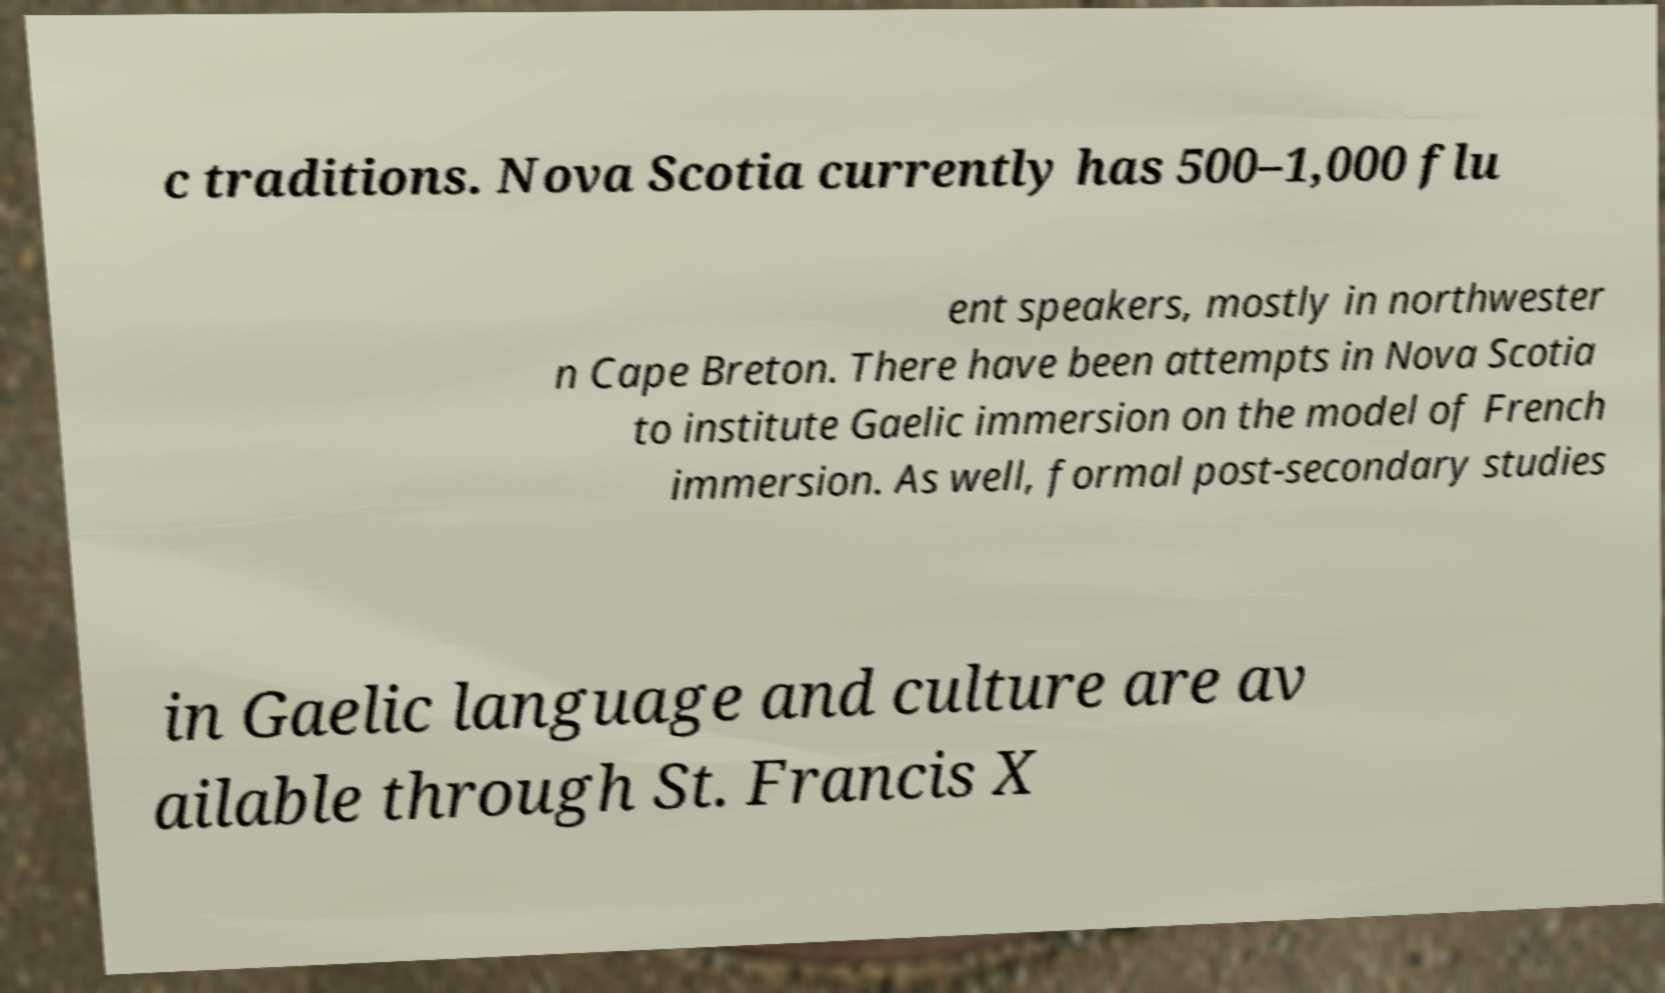What messages or text are displayed in this image? I need them in a readable, typed format. c traditions. Nova Scotia currently has 500–1,000 flu ent speakers, mostly in northwester n Cape Breton. There have been attempts in Nova Scotia to institute Gaelic immersion on the model of French immersion. As well, formal post-secondary studies in Gaelic language and culture are av ailable through St. Francis X 